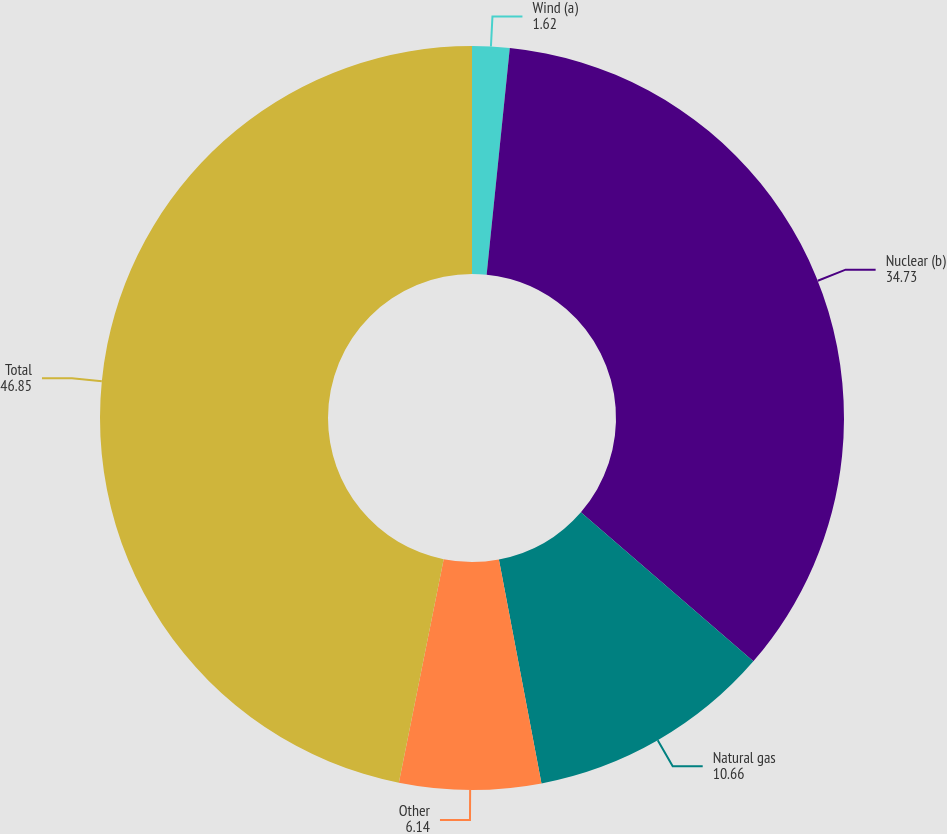<chart> <loc_0><loc_0><loc_500><loc_500><pie_chart><fcel>Wind (a)<fcel>Nuclear (b)<fcel>Natural gas<fcel>Other<fcel>Total<nl><fcel>1.62%<fcel>34.73%<fcel>10.66%<fcel>6.14%<fcel>46.85%<nl></chart> 